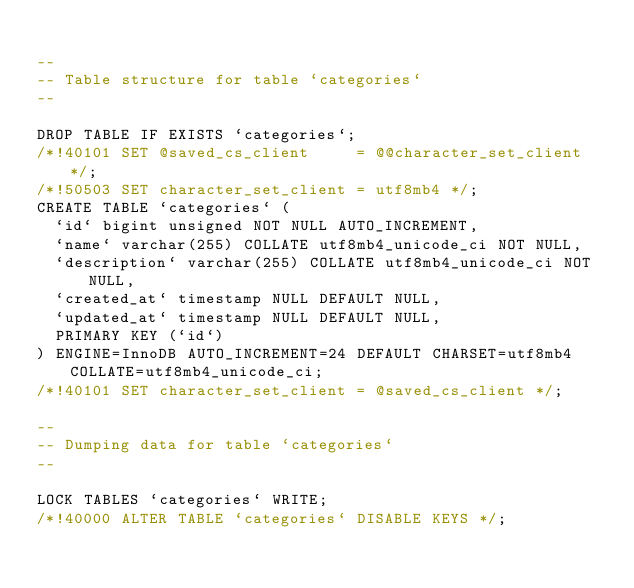<code> <loc_0><loc_0><loc_500><loc_500><_SQL_>
--
-- Table structure for table `categories`
--

DROP TABLE IF EXISTS `categories`;
/*!40101 SET @saved_cs_client     = @@character_set_client */;
/*!50503 SET character_set_client = utf8mb4 */;
CREATE TABLE `categories` (
  `id` bigint unsigned NOT NULL AUTO_INCREMENT,
  `name` varchar(255) COLLATE utf8mb4_unicode_ci NOT NULL,
  `description` varchar(255) COLLATE utf8mb4_unicode_ci NOT NULL,
  `created_at` timestamp NULL DEFAULT NULL,
  `updated_at` timestamp NULL DEFAULT NULL,
  PRIMARY KEY (`id`)
) ENGINE=InnoDB AUTO_INCREMENT=24 DEFAULT CHARSET=utf8mb4 COLLATE=utf8mb4_unicode_ci;
/*!40101 SET character_set_client = @saved_cs_client */;

--
-- Dumping data for table `categories`
--

LOCK TABLES `categories` WRITE;
/*!40000 ALTER TABLE `categories` DISABLE KEYS */;</code> 